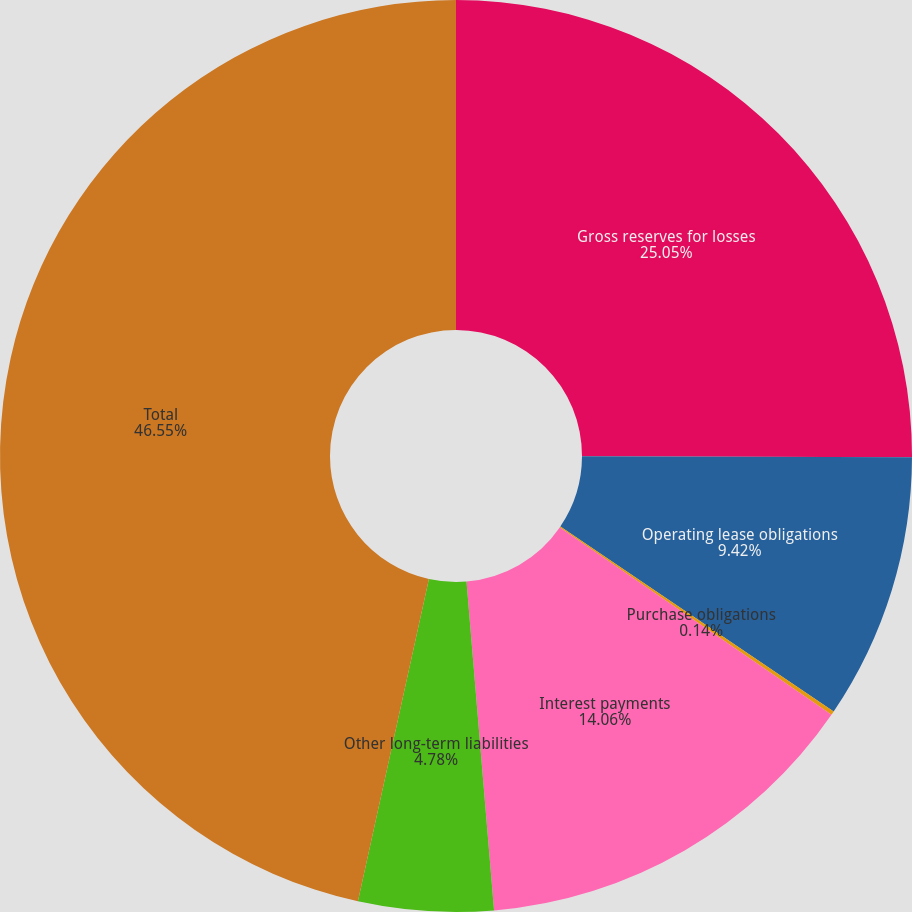Convert chart to OTSL. <chart><loc_0><loc_0><loc_500><loc_500><pie_chart><fcel>Gross reserves for losses<fcel>Operating lease obligations<fcel>Purchase obligations<fcel>Interest payments<fcel>Other long-term liabilities<fcel>Total<nl><fcel>25.04%<fcel>9.42%<fcel>0.14%<fcel>14.06%<fcel>4.78%<fcel>46.54%<nl></chart> 